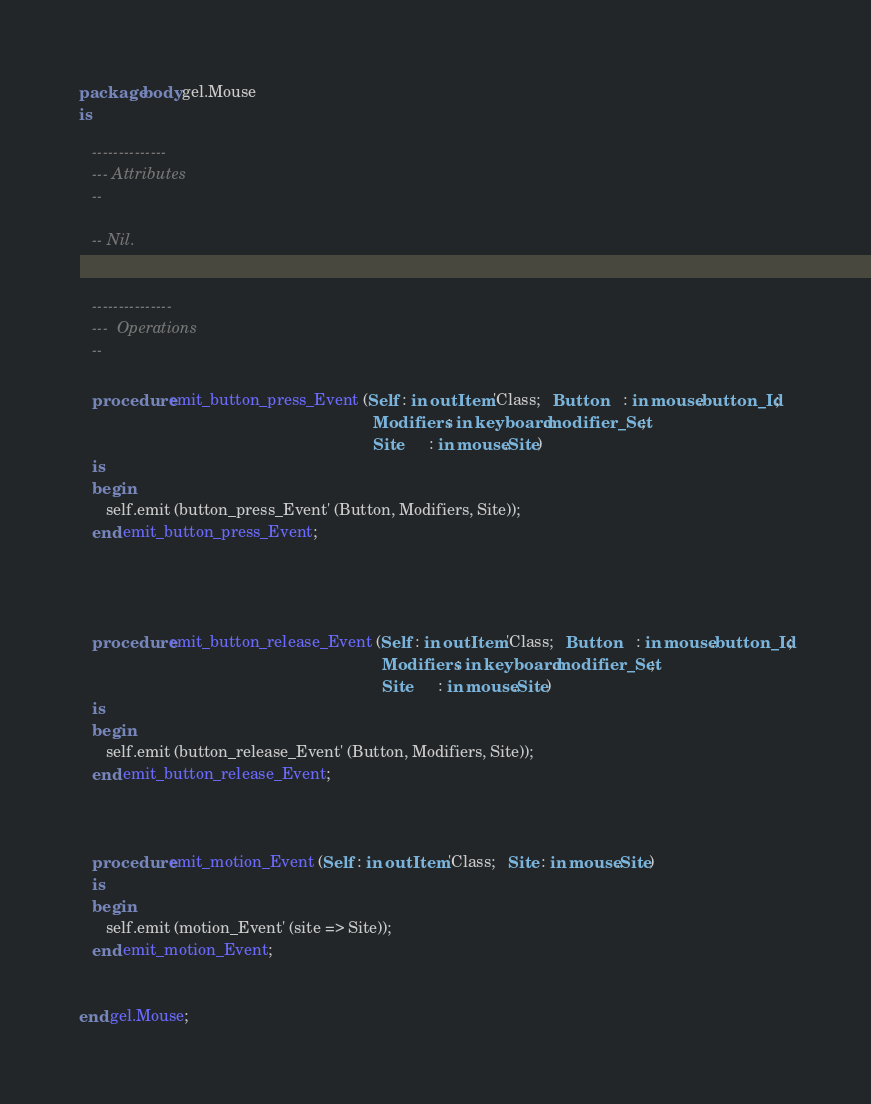Convert code to text. <code><loc_0><loc_0><loc_500><loc_500><_Ada_>package body gel.Mouse
is

   --------------
   --- Attributes
   --

   -- Nil.


   ---------------
   ---  Operations
   --

   procedure emit_button_press_Event (Self : in out Item'Class;   Button    : in mouse.button_Id;
                                                                  Modifiers : in keyboard.modifier_Set;
                                                                  Site      : in mouse.Site)
   is
   begin
      self.emit (button_press_Event' (Button, Modifiers, Site));
   end emit_button_press_Event;




   procedure emit_button_release_Event (Self : in out Item'Class;   Button    : in mouse.button_Id;
                                                                    Modifiers : in keyboard.modifier_Set;
                                                                    Site      : in mouse.Site)
   is
   begin
      self.emit (button_release_Event' (Button, Modifiers, Site));
   end emit_button_release_Event;



   procedure emit_motion_Event (Self : in out Item'Class;   Site : in mouse.Site)
   is
   begin
      self.emit (motion_Event' (site => Site));
   end emit_motion_Event;


end gel.Mouse;
</code> 